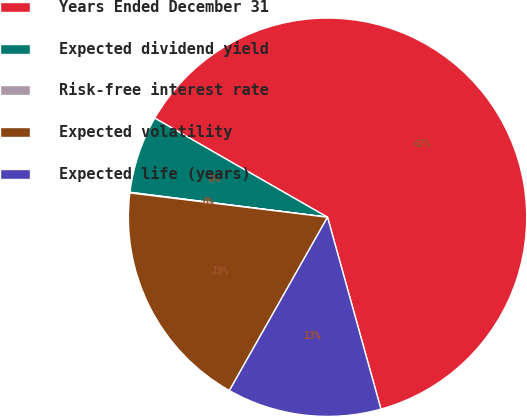Convert chart. <chart><loc_0><loc_0><loc_500><loc_500><pie_chart><fcel>Years Ended December 31<fcel>Expected dividend yield<fcel>Risk-free interest rate<fcel>Expected volatility<fcel>Expected life (years)<nl><fcel>62.39%<fcel>6.29%<fcel>0.05%<fcel>18.75%<fcel>12.52%<nl></chart> 